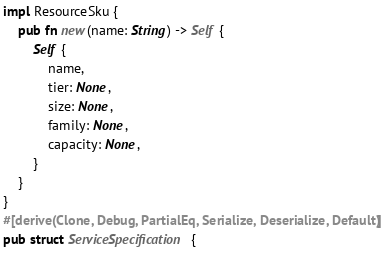Convert code to text. <code><loc_0><loc_0><loc_500><loc_500><_Rust_>impl ResourceSku {
    pub fn new(name: String) -> Self {
        Self {
            name,
            tier: None,
            size: None,
            family: None,
            capacity: None,
        }
    }
}
#[derive(Clone, Debug, PartialEq, Serialize, Deserialize, Default)]
pub struct ServiceSpecification {</code> 